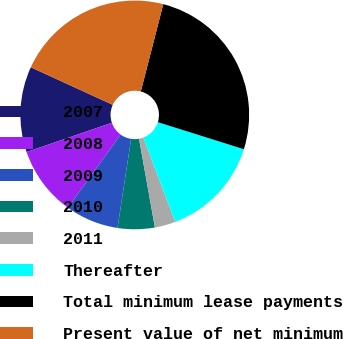<chart> <loc_0><loc_0><loc_500><loc_500><pie_chart><fcel>2007<fcel>2008<fcel>2009<fcel>2010<fcel>2011<fcel>Thereafter<fcel>Total minimum lease payments<fcel>Present value of net minimum<nl><fcel>12.1%<fcel>9.81%<fcel>7.52%<fcel>5.23%<fcel>2.94%<fcel>14.39%<fcel>25.84%<fcel>22.17%<nl></chart> 